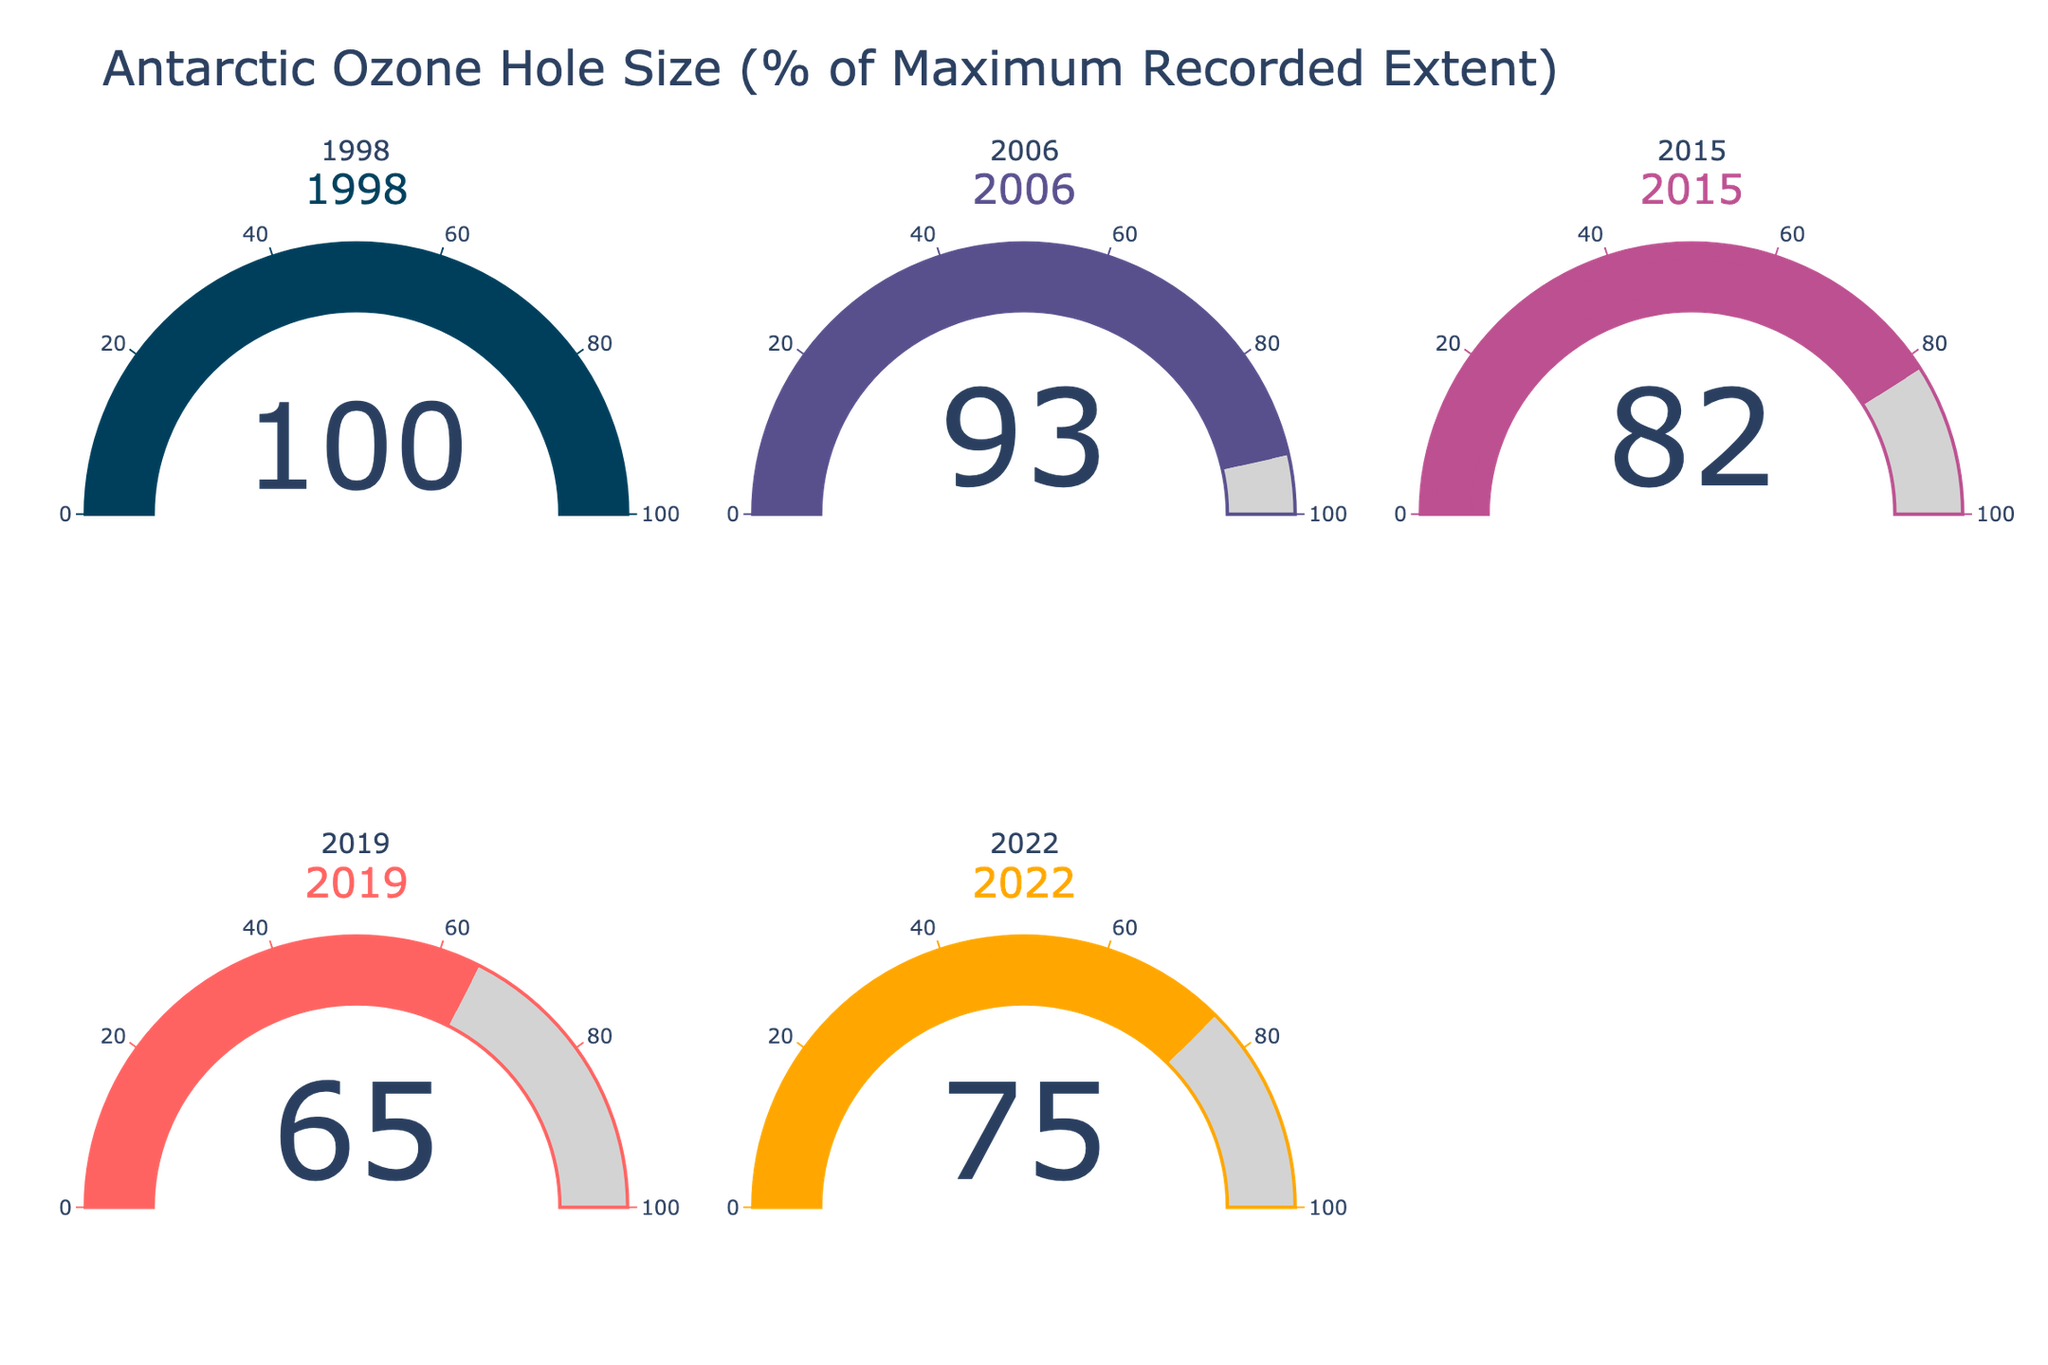How many years are depicted in the figure? The figure displays a gauge chart for each year, and by counting them, we find there are 5 gauges, representing different years.
Answer: 5 What is the title of the chart? The title of the chart is displayed at the top and reads "Antarctic Ozone Hole Size (% of Maximum Recorded Extent)."
Answer: Antarctic Ozone Hole Size (% of Maximum Recorded Extent) Which year had the smallest ozone hole as a percentage of its maximum recorded extent? By looking at each gauge and comparing the values, we can see that 2019 has the smallest percentage value of 65%.
Answer: 2019 What's the average percentage of the ozone hole sizes across all years shown? The percentages are given as 100, 93, 82, 65, and 75. To find the average, sum these values (100 + 93 + 82 + 65 + 75 = 415) and divide by the number of values (415 / 5 = 83).
Answer: 83 Which year had an ozone hole size greater than 80% of its maximum recorded extent but less than 90%? By inspecting the values on each gauge, 2015 shows a value of 82%, which is between 80% and 90%.
Answer: 2015 Is the ozone hole size in 2019 greater or smaller than in 2022? According to the chart, the ozone hole size in 2019 is 65%, while in 2022 it is 75%, meaning 2019's ozone hole size is smaller.
Answer: Smaller What is the difference in percentage between the ozone hole sizes of the years with the largest and smallest values? The largest value is 100% in 1998 and the smallest is 65% in 2019. The difference is 100 - 65 = 35%.
Answer: 35% Which year showed an improvement of the ozone hole size compared to 2022? By comparing values, 2019 (65%) showed a better condition (smaller ozone hole size) compared to 2022 (75%).
Answer: 2019 What color is associated with the smallest ozone hole size displayed on the chart? The gauge for the year 2019, which has the smallest value of 65%, is associated with a unique color in the color scale provided in the description, which is '#ff6361'.
Answer: #ff6361 